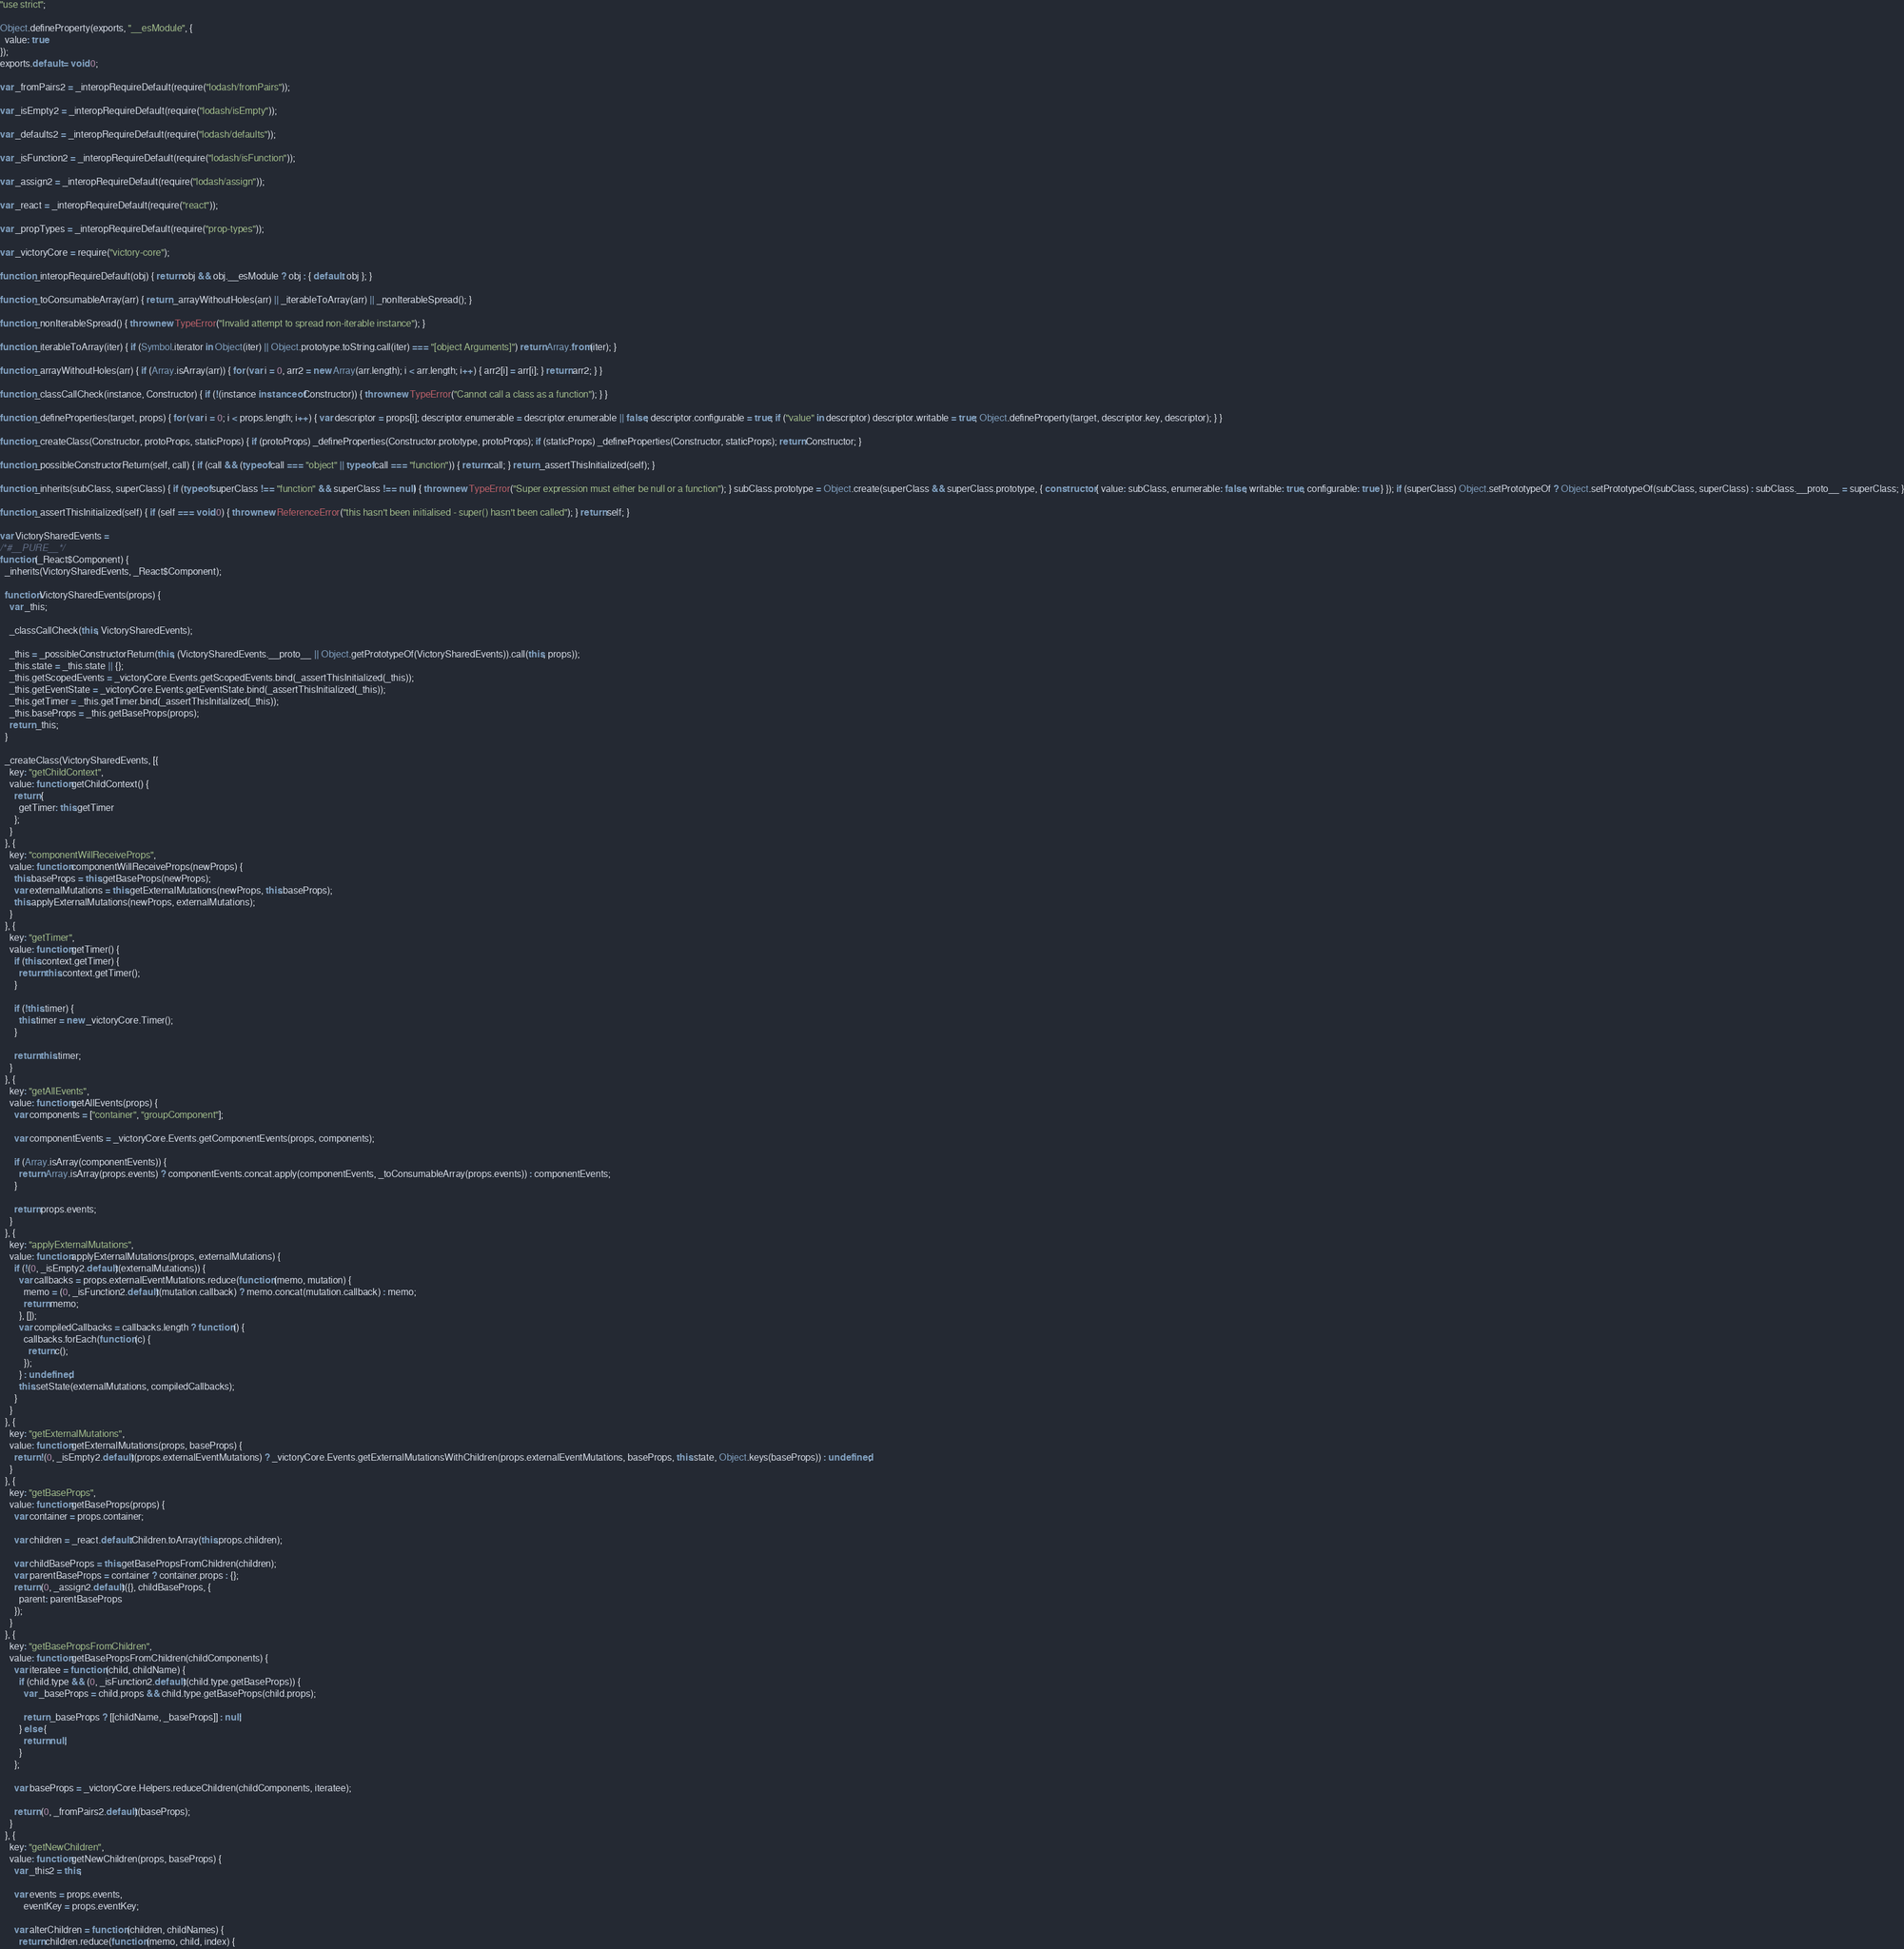Convert code to text. <code><loc_0><loc_0><loc_500><loc_500><_JavaScript_>"use strict";

Object.defineProperty(exports, "__esModule", {
  value: true
});
exports.default = void 0;

var _fromPairs2 = _interopRequireDefault(require("lodash/fromPairs"));

var _isEmpty2 = _interopRequireDefault(require("lodash/isEmpty"));

var _defaults2 = _interopRequireDefault(require("lodash/defaults"));

var _isFunction2 = _interopRequireDefault(require("lodash/isFunction"));

var _assign2 = _interopRequireDefault(require("lodash/assign"));

var _react = _interopRequireDefault(require("react"));

var _propTypes = _interopRequireDefault(require("prop-types"));

var _victoryCore = require("victory-core");

function _interopRequireDefault(obj) { return obj && obj.__esModule ? obj : { default: obj }; }

function _toConsumableArray(arr) { return _arrayWithoutHoles(arr) || _iterableToArray(arr) || _nonIterableSpread(); }

function _nonIterableSpread() { throw new TypeError("Invalid attempt to spread non-iterable instance"); }

function _iterableToArray(iter) { if (Symbol.iterator in Object(iter) || Object.prototype.toString.call(iter) === "[object Arguments]") return Array.from(iter); }

function _arrayWithoutHoles(arr) { if (Array.isArray(arr)) { for (var i = 0, arr2 = new Array(arr.length); i < arr.length; i++) { arr2[i] = arr[i]; } return arr2; } }

function _classCallCheck(instance, Constructor) { if (!(instance instanceof Constructor)) { throw new TypeError("Cannot call a class as a function"); } }

function _defineProperties(target, props) { for (var i = 0; i < props.length; i++) { var descriptor = props[i]; descriptor.enumerable = descriptor.enumerable || false; descriptor.configurable = true; if ("value" in descriptor) descriptor.writable = true; Object.defineProperty(target, descriptor.key, descriptor); } }

function _createClass(Constructor, protoProps, staticProps) { if (protoProps) _defineProperties(Constructor.prototype, protoProps); if (staticProps) _defineProperties(Constructor, staticProps); return Constructor; }

function _possibleConstructorReturn(self, call) { if (call && (typeof call === "object" || typeof call === "function")) { return call; } return _assertThisInitialized(self); }

function _inherits(subClass, superClass) { if (typeof superClass !== "function" && superClass !== null) { throw new TypeError("Super expression must either be null or a function"); } subClass.prototype = Object.create(superClass && superClass.prototype, { constructor: { value: subClass, enumerable: false, writable: true, configurable: true } }); if (superClass) Object.setPrototypeOf ? Object.setPrototypeOf(subClass, superClass) : subClass.__proto__ = superClass; }

function _assertThisInitialized(self) { if (self === void 0) { throw new ReferenceError("this hasn't been initialised - super() hasn't been called"); } return self; }

var VictorySharedEvents =
/*#__PURE__*/
function (_React$Component) {
  _inherits(VictorySharedEvents, _React$Component);

  function VictorySharedEvents(props) {
    var _this;

    _classCallCheck(this, VictorySharedEvents);

    _this = _possibleConstructorReturn(this, (VictorySharedEvents.__proto__ || Object.getPrototypeOf(VictorySharedEvents)).call(this, props));
    _this.state = _this.state || {};
    _this.getScopedEvents = _victoryCore.Events.getScopedEvents.bind(_assertThisInitialized(_this));
    _this.getEventState = _victoryCore.Events.getEventState.bind(_assertThisInitialized(_this));
    _this.getTimer = _this.getTimer.bind(_assertThisInitialized(_this));
    _this.baseProps = _this.getBaseProps(props);
    return _this;
  }

  _createClass(VictorySharedEvents, [{
    key: "getChildContext",
    value: function getChildContext() {
      return {
        getTimer: this.getTimer
      };
    }
  }, {
    key: "componentWillReceiveProps",
    value: function componentWillReceiveProps(newProps) {
      this.baseProps = this.getBaseProps(newProps);
      var externalMutations = this.getExternalMutations(newProps, this.baseProps);
      this.applyExternalMutations(newProps, externalMutations);
    }
  }, {
    key: "getTimer",
    value: function getTimer() {
      if (this.context.getTimer) {
        return this.context.getTimer();
      }

      if (!this.timer) {
        this.timer = new _victoryCore.Timer();
      }

      return this.timer;
    }
  }, {
    key: "getAllEvents",
    value: function getAllEvents(props) {
      var components = ["container", "groupComponent"];

      var componentEvents = _victoryCore.Events.getComponentEvents(props, components);

      if (Array.isArray(componentEvents)) {
        return Array.isArray(props.events) ? componentEvents.concat.apply(componentEvents, _toConsumableArray(props.events)) : componentEvents;
      }

      return props.events;
    }
  }, {
    key: "applyExternalMutations",
    value: function applyExternalMutations(props, externalMutations) {
      if (!(0, _isEmpty2.default)(externalMutations)) {
        var callbacks = props.externalEventMutations.reduce(function (memo, mutation) {
          memo = (0, _isFunction2.default)(mutation.callback) ? memo.concat(mutation.callback) : memo;
          return memo;
        }, []);
        var compiledCallbacks = callbacks.length ? function () {
          callbacks.forEach(function (c) {
            return c();
          });
        } : undefined;
        this.setState(externalMutations, compiledCallbacks);
      }
    }
  }, {
    key: "getExternalMutations",
    value: function getExternalMutations(props, baseProps) {
      return !(0, _isEmpty2.default)(props.externalEventMutations) ? _victoryCore.Events.getExternalMutationsWithChildren(props.externalEventMutations, baseProps, this.state, Object.keys(baseProps)) : undefined;
    }
  }, {
    key: "getBaseProps",
    value: function getBaseProps(props) {
      var container = props.container;

      var children = _react.default.Children.toArray(this.props.children);

      var childBaseProps = this.getBasePropsFromChildren(children);
      var parentBaseProps = container ? container.props : {};
      return (0, _assign2.default)({}, childBaseProps, {
        parent: parentBaseProps
      });
    }
  }, {
    key: "getBasePropsFromChildren",
    value: function getBasePropsFromChildren(childComponents) {
      var iteratee = function (child, childName) {
        if (child.type && (0, _isFunction2.default)(child.type.getBaseProps)) {
          var _baseProps = child.props && child.type.getBaseProps(child.props);

          return _baseProps ? [[childName, _baseProps]] : null;
        } else {
          return null;
        }
      };

      var baseProps = _victoryCore.Helpers.reduceChildren(childComponents, iteratee);

      return (0, _fromPairs2.default)(baseProps);
    }
  }, {
    key: "getNewChildren",
    value: function getNewChildren(props, baseProps) {
      var _this2 = this;

      var events = props.events,
          eventKey = props.eventKey;

      var alterChildren = function (children, childNames) {
        return children.reduce(function (memo, child, index) {</code> 